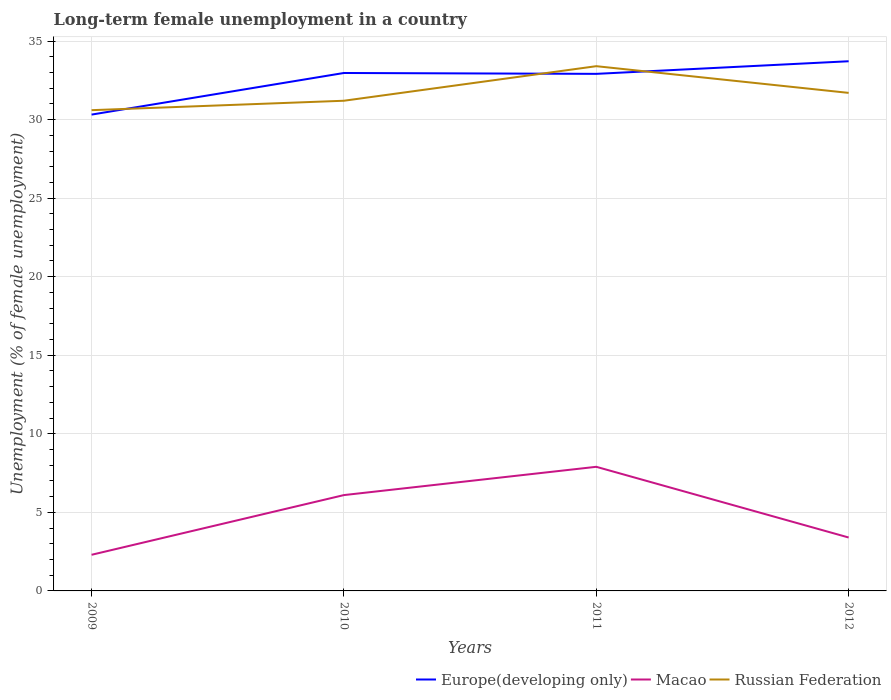Does the line corresponding to Europe(developing only) intersect with the line corresponding to Russian Federation?
Offer a terse response. Yes. Across all years, what is the maximum percentage of long-term unemployed female population in Russian Federation?
Your answer should be compact. 30.6. In which year was the percentage of long-term unemployed female population in Europe(developing only) maximum?
Provide a succinct answer. 2009. What is the total percentage of long-term unemployed female population in Macao in the graph?
Your answer should be very brief. -1.1. What is the difference between the highest and the second highest percentage of long-term unemployed female population in Macao?
Make the answer very short. 5.6. What is the difference between the highest and the lowest percentage of long-term unemployed female population in Macao?
Your answer should be compact. 2. How many years are there in the graph?
Ensure brevity in your answer.  4. Are the values on the major ticks of Y-axis written in scientific E-notation?
Ensure brevity in your answer.  No. Where does the legend appear in the graph?
Offer a very short reply. Bottom right. How many legend labels are there?
Provide a succinct answer. 3. What is the title of the graph?
Your response must be concise. Long-term female unemployment in a country. What is the label or title of the X-axis?
Your response must be concise. Years. What is the label or title of the Y-axis?
Offer a very short reply. Unemployment (% of female unemployment). What is the Unemployment (% of female unemployment) of Europe(developing only) in 2009?
Offer a terse response. 30.32. What is the Unemployment (% of female unemployment) in Macao in 2009?
Offer a terse response. 2.3. What is the Unemployment (% of female unemployment) in Russian Federation in 2009?
Keep it short and to the point. 30.6. What is the Unemployment (% of female unemployment) of Europe(developing only) in 2010?
Offer a terse response. 32.97. What is the Unemployment (% of female unemployment) in Macao in 2010?
Give a very brief answer. 6.1. What is the Unemployment (% of female unemployment) in Russian Federation in 2010?
Provide a short and direct response. 31.2. What is the Unemployment (% of female unemployment) in Europe(developing only) in 2011?
Provide a succinct answer. 32.91. What is the Unemployment (% of female unemployment) of Macao in 2011?
Ensure brevity in your answer.  7.9. What is the Unemployment (% of female unemployment) of Russian Federation in 2011?
Your response must be concise. 33.4. What is the Unemployment (% of female unemployment) of Europe(developing only) in 2012?
Offer a very short reply. 33.71. What is the Unemployment (% of female unemployment) in Macao in 2012?
Give a very brief answer. 3.4. What is the Unemployment (% of female unemployment) of Russian Federation in 2012?
Provide a short and direct response. 31.7. Across all years, what is the maximum Unemployment (% of female unemployment) in Europe(developing only)?
Ensure brevity in your answer.  33.71. Across all years, what is the maximum Unemployment (% of female unemployment) in Macao?
Give a very brief answer. 7.9. Across all years, what is the maximum Unemployment (% of female unemployment) in Russian Federation?
Your answer should be very brief. 33.4. Across all years, what is the minimum Unemployment (% of female unemployment) in Europe(developing only)?
Provide a succinct answer. 30.32. Across all years, what is the minimum Unemployment (% of female unemployment) in Macao?
Your answer should be compact. 2.3. Across all years, what is the minimum Unemployment (% of female unemployment) of Russian Federation?
Keep it short and to the point. 30.6. What is the total Unemployment (% of female unemployment) in Europe(developing only) in the graph?
Offer a very short reply. 129.91. What is the total Unemployment (% of female unemployment) in Russian Federation in the graph?
Offer a terse response. 126.9. What is the difference between the Unemployment (% of female unemployment) of Europe(developing only) in 2009 and that in 2010?
Provide a short and direct response. -2.65. What is the difference between the Unemployment (% of female unemployment) in Europe(developing only) in 2009 and that in 2011?
Ensure brevity in your answer.  -2.59. What is the difference between the Unemployment (% of female unemployment) in Macao in 2009 and that in 2011?
Offer a terse response. -5.6. What is the difference between the Unemployment (% of female unemployment) of Europe(developing only) in 2009 and that in 2012?
Ensure brevity in your answer.  -3.4. What is the difference between the Unemployment (% of female unemployment) of Macao in 2009 and that in 2012?
Offer a terse response. -1.1. What is the difference between the Unemployment (% of female unemployment) of Europe(developing only) in 2010 and that in 2011?
Offer a terse response. 0.06. What is the difference between the Unemployment (% of female unemployment) in Russian Federation in 2010 and that in 2011?
Keep it short and to the point. -2.2. What is the difference between the Unemployment (% of female unemployment) in Europe(developing only) in 2010 and that in 2012?
Your response must be concise. -0.75. What is the difference between the Unemployment (% of female unemployment) in Russian Federation in 2010 and that in 2012?
Your answer should be very brief. -0.5. What is the difference between the Unemployment (% of female unemployment) in Europe(developing only) in 2011 and that in 2012?
Offer a very short reply. -0.8. What is the difference between the Unemployment (% of female unemployment) of Europe(developing only) in 2009 and the Unemployment (% of female unemployment) of Macao in 2010?
Make the answer very short. 24.22. What is the difference between the Unemployment (% of female unemployment) of Europe(developing only) in 2009 and the Unemployment (% of female unemployment) of Russian Federation in 2010?
Provide a short and direct response. -0.88. What is the difference between the Unemployment (% of female unemployment) in Macao in 2009 and the Unemployment (% of female unemployment) in Russian Federation in 2010?
Your answer should be very brief. -28.9. What is the difference between the Unemployment (% of female unemployment) in Europe(developing only) in 2009 and the Unemployment (% of female unemployment) in Macao in 2011?
Keep it short and to the point. 22.42. What is the difference between the Unemployment (% of female unemployment) in Europe(developing only) in 2009 and the Unemployment (% of female unemployment) in Russian Federation in 2011?
Ensure brevity in your answer.  -3.08. What is the difference between the Unemployment (% of female unemployment) of Macao in 2009 and the Unemployment (% of female unemployment) of Russian Federation in 2011?
Offer a very short reply. -31.1. What is the difference between the Unemployment (% of female unemployment) in Europe(developing only) in 2009 and the Unemployment (% of female unemployment) in Macao in 2012?
Make the answer very short. 26.92. What is the difference between the Unemployment (% of female unemployment) in Europe(developing only) in 2009 and the Unemployment (% of female unemployment) in Russian Federation in 2012?
Offer a very short reply. -1.38. What is the difference between the Unemployment (% of female unemployment) in Macao in 2009 and the Unemployment (% of female unemployment) in Russian Federation in 2012?
Ensure brevity in your answer.  -29.4. What is the difference between the Unemployment (% of female unemployment) in Europe(developing only) in 2010 and the Unemployment (% of female unemployment) in Macao in 2011?
Give a very brief answer. 25.07. What is the difference between the Unemployment (% of female unemployment) of Europe(developing only) in 2010 and the Unemployment (% of female unemployment) of Russian Federation in 2011?
Offer a terse response. -0.43. What is the difference between the Unemployment (% of female unemployment) in Macao in 2010 and the Unemployment (% of female unemployment) in Russian Federation in 2011?
Give a very brief answer. -27.3. What is the difference between the Unemployment (% of female unemployment) of Europe(developing only) in 2010 and the Unemployment (% of female unemployment) of Macao in 2012?
Offer a very short reply. 29.57. What is the difference between the Unemployment (% of female unemployment) of Europe(developing only) in 2010 and the Unemployment (% of female unemployment) of Russian Federation in 2012?
Offer a terse response. 1.27. What is the difference between the Unemployment (% of female unemployment) of Macao in 2010 and the Unemployment (% of female unemployment) of Russian Federation in 2012?
Keep it short and to the point. -25.6. What is the difference between the Unemployment (% of female unemployment) in Europe(developing only) in 2011 and the Unemployment (% of female unemployment) in Macao in 2012?
Provide a succinct answer. 29.51. What is the difference between the Unemployment (% of female unemployment) of Europe(developing only) in 2011 and the Unemployment (% of female unemployment) of Russian Federation in 2012?
Give a very brief answer. 1.21. What is the difference between the Unemployment (% of female unemployment) of Macao in 2011 and the Unemployment (% of female unemployment) of Russian Federation in 2012?
Provide a short and direct response. -23.8. What is the average Unemployment (% of female unemployment) in Europe(developing only) per year?
Keep it short and to the point. 32.48. What is the average Unemployment (% of female unemployment) of Macao per year?
Provide a short and direct response. 4.92. What is the average Unemployment (% of female unemployment) of Russian Federation per year?
Your response must be concise. 31.73. In the year 2009, what is the difference between the Unemployment (% of female unemployment) of Europe(developing only) and Unemployment (% of female unemployment) of Macao?
Ensure brevity in your answer.  28.02. In the year 2009, what is the difference between the Unemployment (% of female unemployment) of Europe(developing only) and Unemployment (% of female unemployment) of Russian Federation?
Provide a succinct answer. -0.28. In the year 2009, what is the difference between the Unemployment (% of female unemployment) of Macao and Unemployment (% of female unemployment) of Russian Federation?
Your response must be concise. -28.3. In the year 2010, what is the difference between the Unemployment (% of female unemployment) in Europe(developing only) and Unemployment (% of female unemployment) in Macao?
Ensure brevity in your answer.  26.87. In the year 2010, what is the difference between the Unemployment (% of female unemployment) of Europe(developing only) and Unemployment (% of female unemployment) of Russian Federation?
Give a very brief answer. 1.77. In the year 2010, what is the difference between the Unemployment (% of female unemployment) in Macao and Unemployment (% of female unemployment) in Russian Federation?
Give a very brief answer. -25.1. In the year 2011, what is the difference between the Unemployment (% of female unemployment) of Europe(developing only) and Unemployment (% of female unemployment) of Macao?
Ensure brevity in your answer.  25.01. In the year 2011, what is the difference between the Unemployment (% of female unemployment) in Europe(developing only) and Unemployment (% of female unemployment) in Russian Federation?
Provide a succinct answer. -0.49. In the year 2011, what is the difference between the Unemployment (% of female unemployment) of Macao and Unemployment (% of female unemployment) of Russian Federation?
Your response must be concise. -25.5. In the year 2012, what is the difference between the Unemployment (% of female unemployment) of Europe(developing only) and Unemployment (% of female unemployment) of Macao?
Your answer should be very brief. 30.31. In the year 2012, what is the difference between the Unemployment (% of female unemployment) of Europe(developing only) and Unemployment (% of female unemployment) of Russian Federation?
Keep it short and to the point. 2.01. In the year 2012, what is the difference between the Unemployment (% of female unemployment) in Macao and Unemployment (% of female unemployment) in Russian Federation?
Offer a terse response. -28.3. What is the ratio of the Unemployment (% of female unemployment) of Europe(developing only) in 2009 to that in 2010?
Make the answer very short. 0.92. What is the ratio of the Unemployment (% of female unemployment) of Macao in 2009 to that in 2010?
Your answer should be compact. 0.38. What is the ratio of the Unemployment (% of female unemployment) of Russian Federation in 2009 to that in 2010?
Provide a succinct answer. 0.98. What is the ratio of the Unemployment (% of female unemployment) in Europe(developing only) in 2009 to that in 2011?
Offer a very short reply. 0.92. What is the ratio of the Unemployment (% of female unemployment) in Macao in 2009 to that in 2011?
Your answer should be compact. 0.29. What is the ratio of the Unemployment (% of female unemployment) of Russian Federation in 2009 to that in 2011?
Make the answer very short. 0.92. What is the ratio of the Unemployment (% of female unemployment) in Europe(developing only) in 2009 to that in 2012?
Keep it short and to the point. 0.9. What is the ratio of the Unemployment (% of female unemployment) of Macao in 2009 to that in 2012?
Your response must be concise. 0.68. What is the ratio of the Unemployment (% of female unemployment) of Russian Federation in 2009 to that in 2012?
Your response must be concise. 0.97. What is the ratio of the Unemployment (% of female unemployment) of Europe(developing only) in 2010 to that in 2011?
Ensure brevity in your answer.  1. What is the ratio of the Unemployment (% of female unemployment) in Macao in 2010 to that in 2011?
Ensure brevity in your answer.  0.77. What is the ratio of the Unemployment (% of female unemployment) of Russian Federation in 2010 to that in 2011?
Keep it short and to the point. 0.93. What is the ratio of the Unemployment (% of female unemployment) in Europe(developing only) in 2010 to that in 2012?
Make the answer very short. 0.98. What is the ratio of the Unemployment (% of female unemployment) of Macao in 2010 to that in 2012?
Offer a very short reply. 1.79. What is the ratio of the Unemployment (% of female unemployment) of Russian Federation in 2010 to that in 2012?
Keep it short and to the point. 0.98. What is the ratio of the Unemployment (% of female unemployment) in Europe(developing only) in 2011 to that in 2012?
Give a very brief answer. 0.98. What is the ratio of the Unemployment (% of female unemployment) of Macao in 2011 to that in 2012?
Provide a succinct answer. 2.32. What is the ratio of the Unemployment (% of female unemployment) of Russian Federation in 2011 to that in 2012?
Provide a short and direct response. 1.05. What is the difference between the highest and the second highest Unemployment (% of female unemployment) of Europe(developing only)?
Your answer should be compact. 0.75. What is the difference between the highest and the second highest Unemployment (% of female unemployment) of Macao?
Provide a short and direct response. 1.8. What is the difference between the highest and the second highest Unemployment (% of female unemployment) in Russian Federation?
Give a very brief answer. 1.7. What is the difference between the highest and the lowest Unemployment (% of female unemployment) of Europe(developing only)?
Keep it short and to the point. 3.4. What is the difference between the highest and the lowest Unemployment (% of female unemployment) in Macao?
Provide a succinct answer. 5.6. 